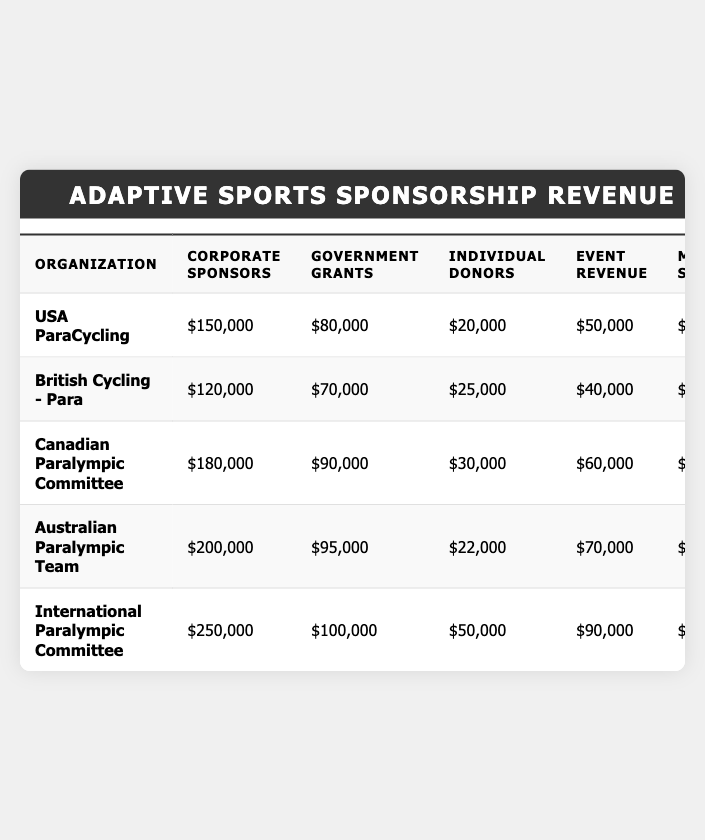What is the total sponsorship revenue for the International Paralympic Committee? You can find the total sponsorship revenue listed in the total column for the International Paralympic Committee row, which is $550,000.
Answer: $550,000 Which organization received the highest amount from corporate sponsors? Looking at the corporate sponsors column, the International Paralympic Committee has the highest value of $250,000 compared to others.
Answer: International Paralympic Committee How much revenue did the Australian Paralympic Team generate from merchandise sales? The merchandise sales for the Australian Paralympic Team can be found in their respective row under the merchandise sales column, which is $40,000.
Answer: $40,000 What is the average government grant amount across all organizations? First sum the government grants: $80,000 + $70,000 + $90,000 + $95,000 + $100,000 = $435,000. There are 5 organizations, so the average is $435,000 / 5 = $87,000.
Answer: $87,000 Did any organization receive more than $300,000 in total revenue? By checking the total column, the International Paralympic Committee ($550,000), Australian Paralympic Team ($427,000), and Canadian Paralympic Committee ($385,000) all received more than $300,000.
Answer: Yes What was the total revenue generated from individual donors across all organizations? Add the values in the individual donors column: $20,000 + $25,000 + $30,000 + $22,000 + $50,000 = $147,000.
Answer: $147,000 Which organization had the lowest total revenue and what was that amount? The total revenue can be seen in the total column; the organization with the lowest total is British Cycling - Para with $290,000.
Answer: $290,000 What is the difference in corporate sponsorships between the Australian Paralympic Team and the Canadian Paralympic Committee? The corporate sponsorship for the Australian Paralympic Team is $200,000 and for the Canadian Paralympic Committee is $180,000. The difference is $200,000 - $180,000 = $20,000.
Answer: $20,000 If we combine the event revenue from all organizations, what would be the total? Adding the event revenue: $50,000 + $40,000 + $60,000 + $70,000 + $90,000 = $310,000.
Answer: $310,000 Is the total revenue for the USA ParaCycling greater than the sum of its corporate sponsors and government grants? For USA ParaCycling, total revenue is $330,000; the sum of corporate sponsors ($150,000) and government grants ($80,000) is $230,000. Since $330,000 > $230,000, the statement is true.
Answer: Yes 